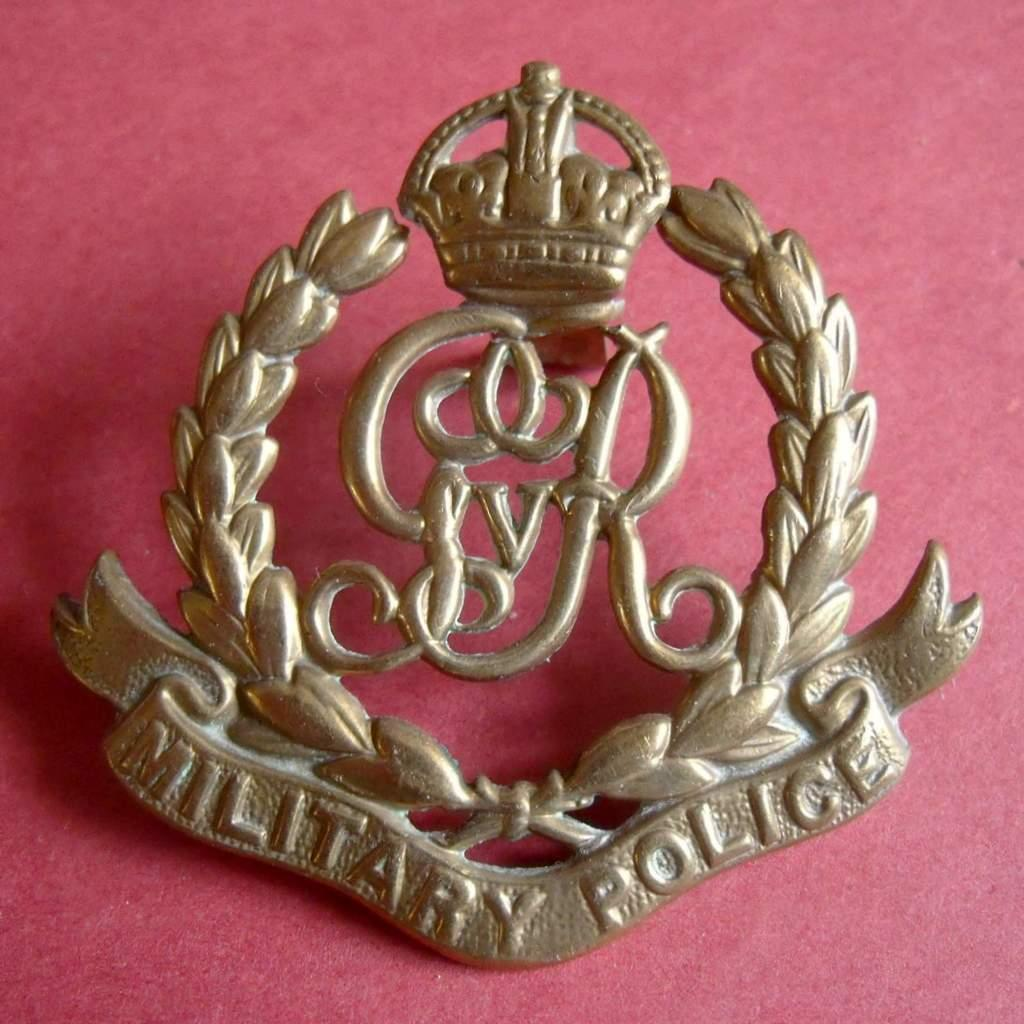What is the main subject in the middle of the image? There is a badge in the middle of the image. Where is the badge located? The badge is on a surface. What color is the background of the image? The background of the image is pink in color. Can you see a boy playing with a cabbage at the seashore in the image? No, there is no boy or cabbage at the seashore in the image; it features a badge on a surface with a pink background. 